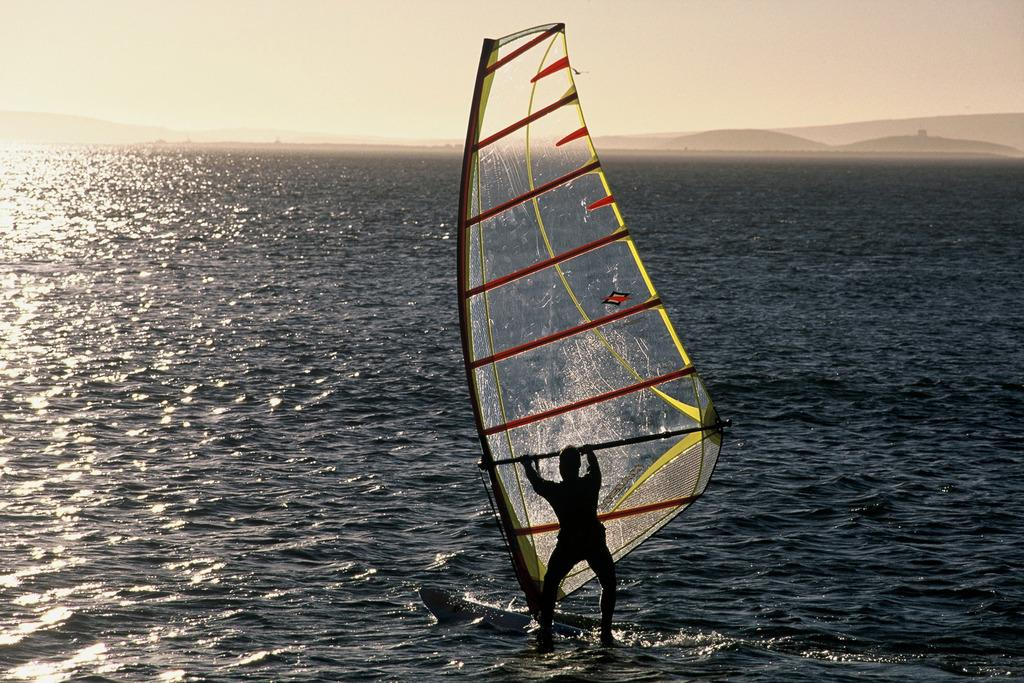What is the person in the image doing? The person is doing windsurfing in the image. Where is the windsurfing activity taking place? The activity is taking place in a river. What can be seen in the background of the image? There is a sky visible in the background of the image. What type of marble is the person using for windsurfing in the image? There is no marble present in the image; the person is windsurfing on a river using a windsurfing board and sail. 